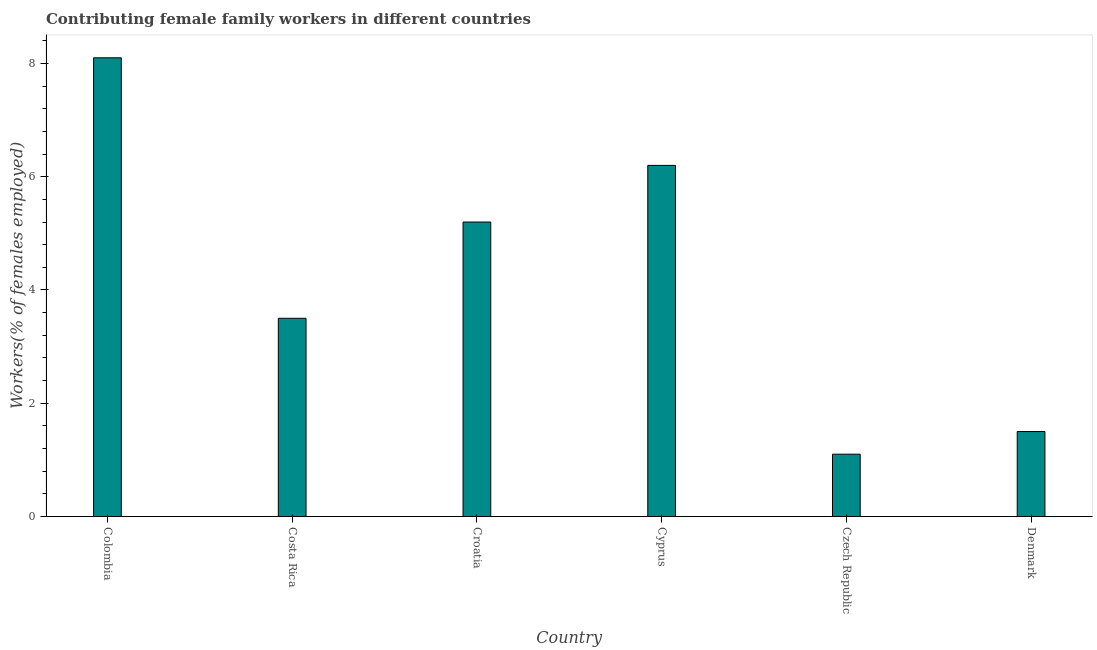Does the graph contain any zero values?
Give a very brief answer. No. Does the graph contain grids?
Provide a short and direct response. No. What is the title of the graph?
Give a very brief answer. Contributing female family workers in different countries. What is the label or title of the X-axis?
Provide a succinct answer. Country. What is the label or title of the Y-axis?
Offer a very short reply. Workers(% of females employed). What is the contributing female family workers in Colombia?
Provide a short and direct response. 8.1. Across all countries, what is the maximum contributing female family workers?
Give a very brief answer. 8.1. Across all countries, what is the minimum contributing female family workers?
Offer a very short reply. 1.1. In which country was the contributing female family workers minimum?
Your response must be concise. Czech Republic. What is the sum of the contributing female family workers?
Give a very brief answer. 25.6. What is the difference between the contributing female family workers in Costa Rica and Croatia?
Your response must be concise. -1.7. What is the average contributing female family workers per country?
Your response must be concise. 4.27. What is the median contributing female family workers?
Provide a succinct answer. 4.35. In how many countries, is the contributing female family workers greater than 5.6 %?
Offer a very short reply. 2. What is the ratio of the contributing female family workers in Colombia to that in Croatia?
Ensure brevity in your answer.  1.56. Is the sum of the contributing female family workers in Colombia and Denmark greater than the maximum contributing female family workers across all countries?
Provide a short and direct response. Yes. In how many countries, is the contributing female family workers greater than the average contributing female family workers taken over all countries?
Keep it short and to the point. 3. How many bars are there?
Make the answer very short. 6. Are all the bars in the graph horizontal?
Your answer should be very brief. No. What is the Workers(% of females employed) of Colombia?
Offer a very short reply. 8.1. What is the Workers(% of females employed) in Costa Rica?
Provide a short and direct response. 3.5. What is the Workers(% of females employed) in Croatia?
Provide a short and direct response. 5.2. What is the Workers(% of females employed) in Cyprus?
Offer a terse response. 6.2. What is the Workers(% of females employed) in Czech Republic?
Your response must be concise. 1.1. What is the difference between the Workers(% of females employed) in Colombia and Cyprus?
Offer a very short reply. 1.9. What is the difference between the Workers(% of females employed) in Colombia and Czech Republic?
Make the answer very short. 7. What is the difference between the Workers(% of females employed) in Costa Rica and Czech Republic?
Make the answer very short. 2.4. What is the difference between the Workers(% of females employed) in Costa Rica and Denmark?
Your answer should be compact. 2. What is the difference between the Workers(% of females employed) in Croatia and Cyprus?
Your answer should be very brief. -1. What is the difference between the Workers(% of females employed) in Croatia and Czech Republic?
Your answer should be compact. 4.1. What is the difference between the Workers(% of females employed) in Croatia and Denmark?
Keep it short and to the point. 3.7. What is the difference between the Workers(% of females employed) in Cyprus and Czech Republic?
Make the answer very short. 5.1. What is the ratio of the Workers(% of females employed) in Colombia to that in Costa Rica?
Keep it short and to the point. 2.31. What is the ratio of the Workers(% of females employed) in Colombia to that in Croatia?
Your answer should be compact. 1.56. What is the ratio of the Workers(% of females employed) in Colombia to that in Cyprus?
Your response must be concise. 1.31. What is the ratio of the Workers(% of females employed) in Colombia to that in Czech Republic?
Provide a short and direct response. 7.36. What is the ratio of the Workers(% of females employed) in Costa Rica to that in Croatia?
Keep it short and to the point. 0.67. What is the ratio of the Workers(% of females employed) in Costa Rica to that in Cyprus?
Offer a terse response. 0.56. What is the ratio of the Workers(% of females employed) in Costa Rica to that in Czech Republic?
Offer a very short reply. 3.18. What is the ratio of the Workers(% of females employed) in Costa Rica to that in Denmark?
Give a very brief answer. 2.33. What is the ratio of the Workers(% of females employed) in Croatia to that in Cyprus?
Provide a succinct answer. 0.84. What is the ratio of the Workers(% of females employed) in Croatia to that in Czech Republic?
Your response must be concise. 4.73. What is the ratio of the Workers(% of females employed) in Croatia to that in Denmark?
Provide a succinct answer. 3.47. What is the ratio of the Workers(% of females employed) in Cyprus to that in Czech Republic?
Keep it short and to the point. 5.64. What is the ratio of the Workers(% of females employed) in Cyprus to that in Denmark?
Your answer should be compact. 4.13. What is the ratio of the Workers(% of females employed) in Czech Republic to that in Denmark?
Give a very brief answer. 0.73. 